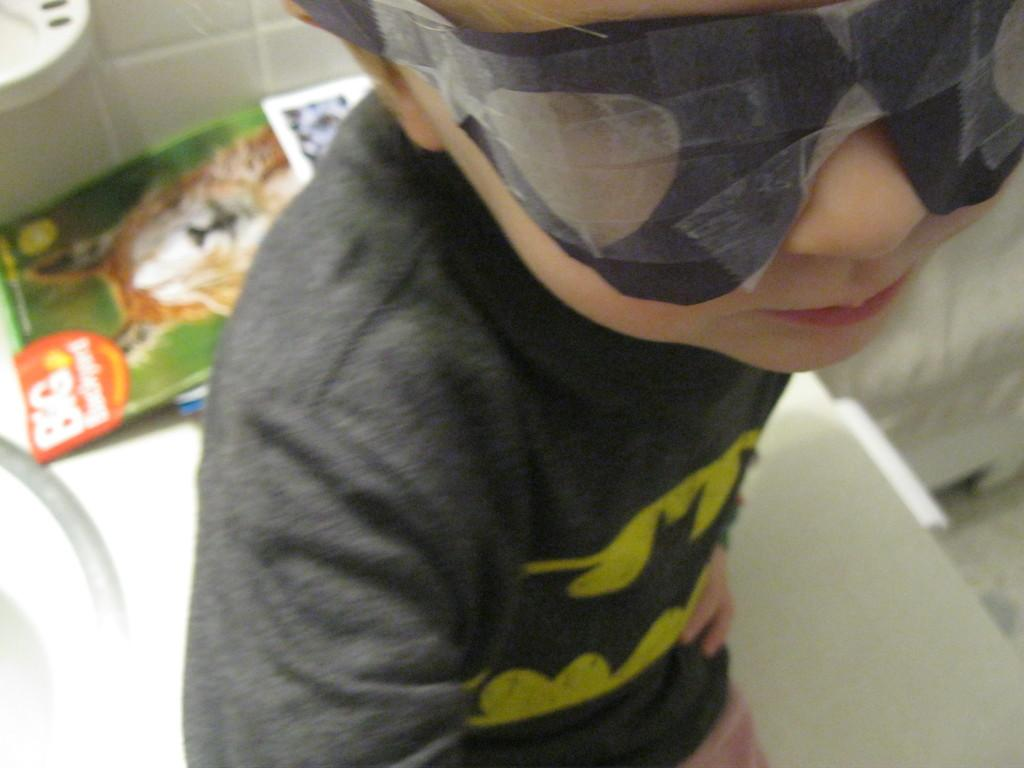What is the main subject of the image? There is a person in the image. What is the person wearing? The person is wearing a black dress and a mask. What else can be seen in the image besides the person? There are books visible in the image, and there is a white surface present. Is the person attempting to play basketball in the image? There is no basketball or any indication of basketball playing in the image. 